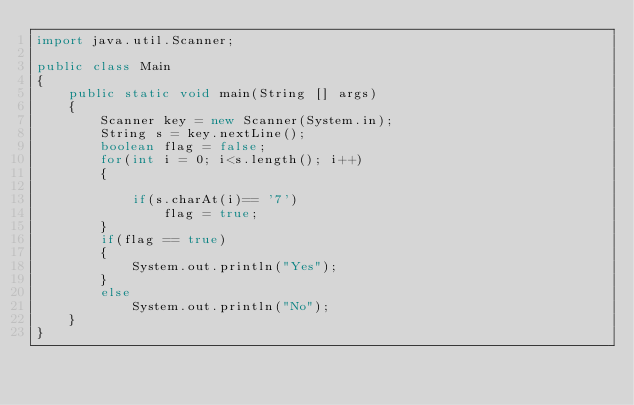Convert code to text. <code><loc_0><loc_0><loc_500><loc_500><_Java_>import java.util.Scanner;

public class Main
{
    public static void main(String [] args)
    {
        Scanner key = new Scanner(System.in);
        String s = key.nextLine();
        boolean flag = false;
        for(int i = 0; i<s.length(); i++)
        {
            
            if(s.charAt(i)== '7')
                flag = true;
        }
        if(flag == true)
        {
            System.out.println("Yes");
        }
        else
            System.out.println("No");
    }
}</code> 